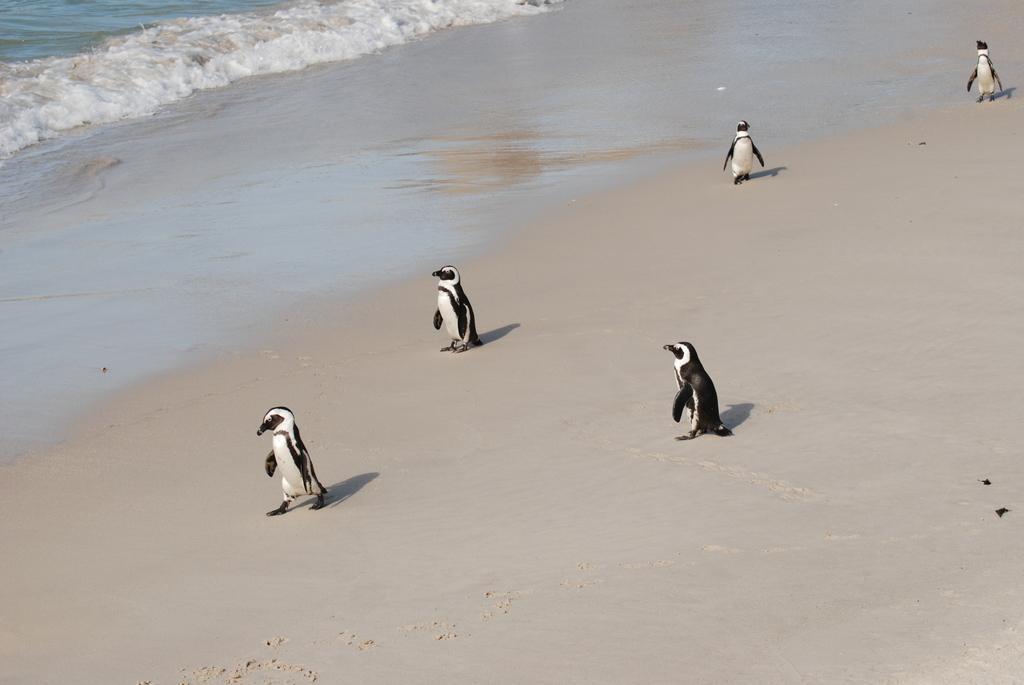How would you summarize this image in a sentence or two? In this picture I can see the sand, on which there are 5 penguins and in the background I can see the water. 